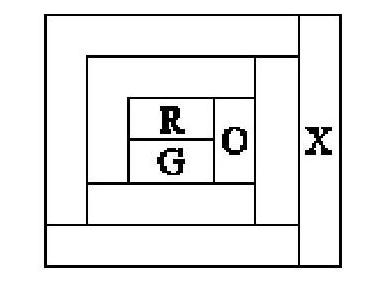If there were a fourth area that 'X' would touch, which did not touch the red or green areas, what could be a possible color for 'X' and the fourth area? If 'X' touches a new area that doesn't touch the red or green ones, we could color 'X' blue (B), and the new area could be any of the remaining colors not touching it, which could be red (R), green (G), or orange (O), depending on what other areas it may touch. 